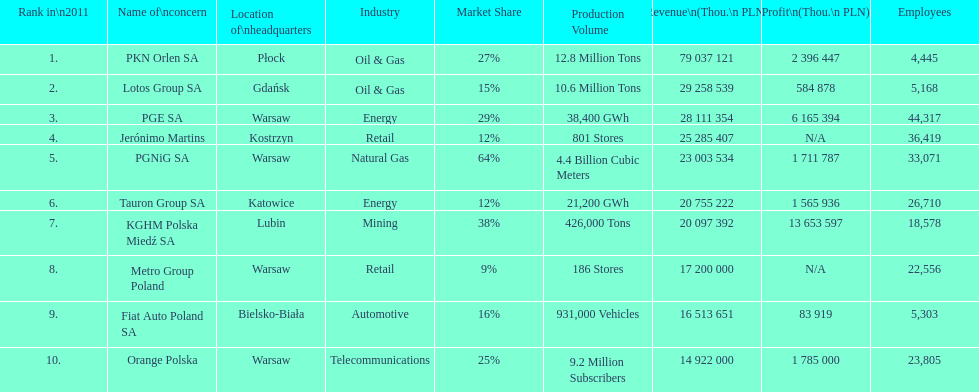What company has the top number of employees? PGE SA. 